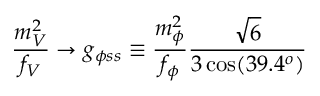Convert formula to latex. <formula><loc_0><loc_0><loc_500><loc_500>\frac { m _ { V } ^ { 2 } } { f _ { V } } \to g _ { \phi s s } \equiv \frac { m _ { \phi } ^ { 2 } } { f _ { \phi } } \frac { \sqrt { 6 } } { 3 \cos ( 3 9 . 4 ^ { o } ) }</formula> 